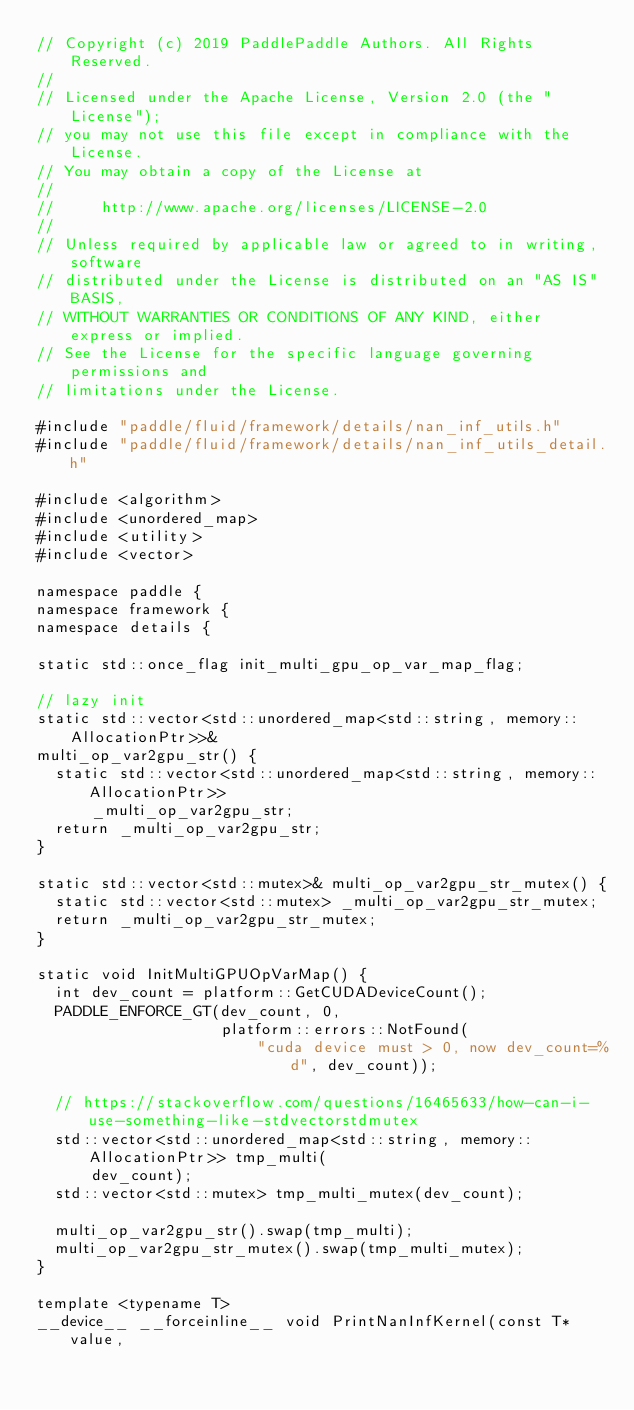<code> <loc_0><loc_0><loc_500><loc_500><_Cuda_>// Copyright (c) 2019 PaddlePaddle Authors. All Rights Reserved.
//
// Licensed under the Apache License, Version 2.0 (the "License");
// you may not use this file except in compliance with the License.
// You may obtain a copy of the License at
//
//     http://www.apache.org/licenses/LICENSE-2.0
//
// Unless required by applicable law or agreed to in writing, software
// distributed under the License is distributed on an "AS IS" BASIS,
// WITHOUT WARRANTIES OR CONDITIONS OF ANY KIND, either express or implied.
// See the License for the specific language governing permissions and
// limitations under the License.

#include "paddle/fluid/framework/details/nan_inf_utils.h"
#include "paddle/fluid/framework/details/nan_inf_utils_detail.h"

#include <algorithm>
#include <unordered_map>
#include <utility>
#include <vector>

namespace paddle {
namespace framework {
namespace details {

static std::once_flag init_multi_gpu_op_var_map_flag;

// lazy init
static std::vector<std::unordered_map<std::string, memory::AllocationPtr>>&
multi_op_var2gpu_str() {
  static std::vector<std::unordered_map<std::string, memory::AllocationPtr>>
      _multi_op_var2gpu_str;
  return _multi_op_var2gpu_str;
}

static std::vector<std::mutex>& multi_op_var2gpu_str_mutex() {
  static std::vector<std::mutex> _multi_op_var2gpu_str_mutex;
  return _multi_op_var2gpu_str_mutex;
}

static void InitMultiGPUOpVarMap() {
  int dev_count = platform::GetCUDADeviceCount();
  PADDLE_ENFORCE_GT(dev_count, 0,
                    platform::errors::NotFound(
                        "cuda device must > 0, now dev_count=%d", dev_count));

  // https://stackoverflow.com/questions/16465633/how-can-i-use-something-like-stdvectorstdmutex
  std::vector<std::unordered_map<std::string, memory::AllocationPtr>> tmp_multi(
      dev_count);
  std::vector<std::mutex> tmp_multi_mutex(dev_count);

  multi_op_var2gpu_str().swap(tmp_multi);
  multi_op_var2gpu_str_mutex().swap(tmp_multi_mutex);
}

template <typename T>
__device__ __forceinline__ void PrintNanInfKernel(const T* value,</code> 